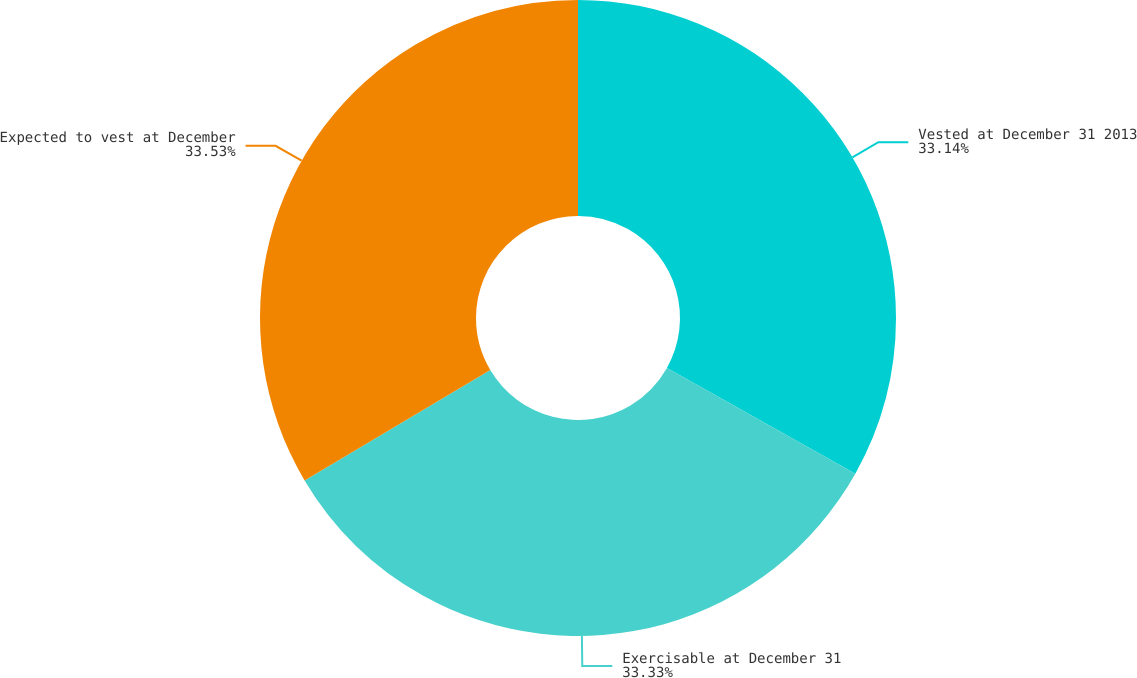Convert chart to OTSL. <chart><loc_0><loc_0><loc_500><loc_500><pie_chart><fcel>Vested at December 31 2013<fcel>Exercisable at December 31<fcel>Expected to vest at December<nl><fcel>33.14%<fcel>33.33%<fcel>33.53%<nl></chart> 